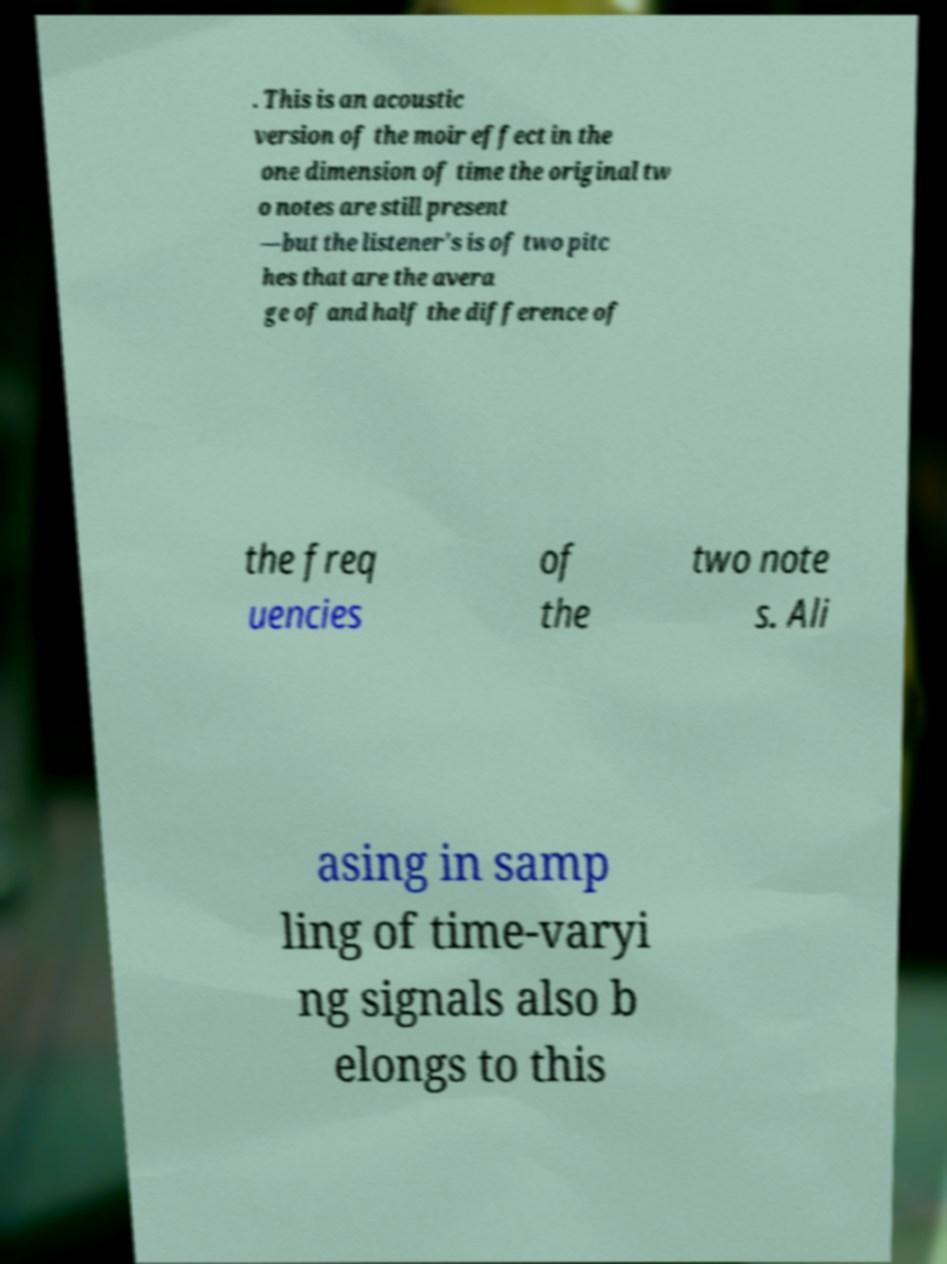Can you accurately transcribe the text from the provided image for me? . This is an acoustic version of the moir effect in the one dimension of time the original tw o notes are still present —but the listener's is of two pitc hes that are the avera ge of and half the difference of the freq uencies of the two note s. Ali asing in samp ling of time-varyi ng signals also b elongs to this 